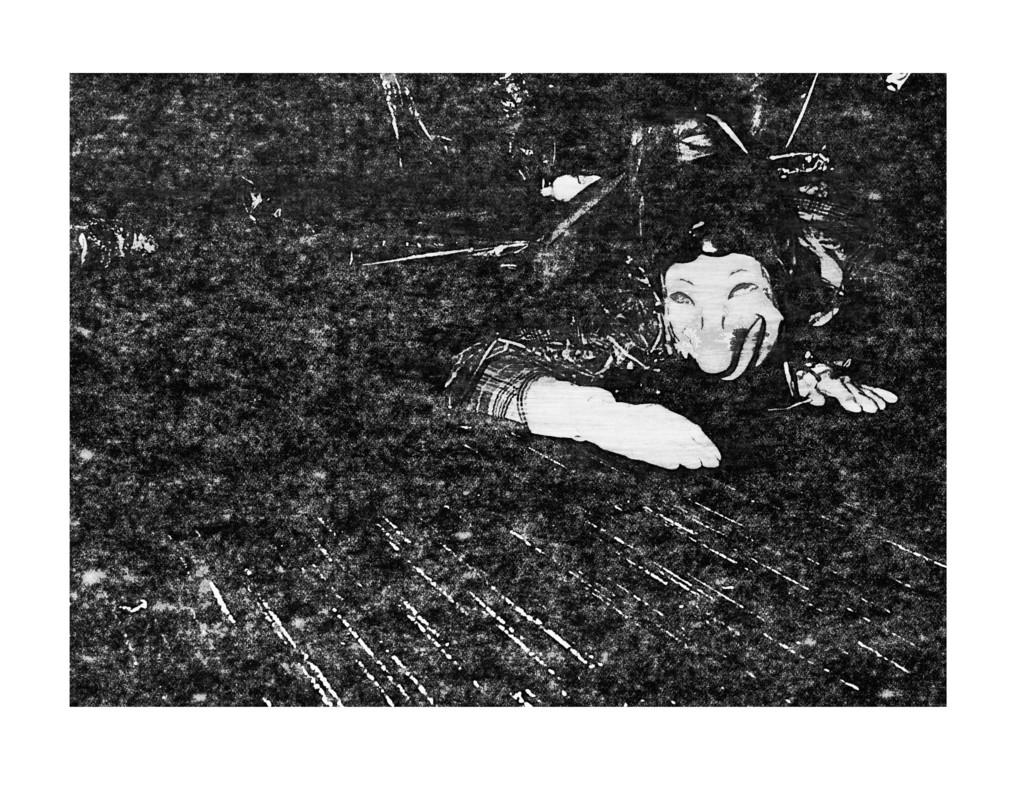What is the overall lighting condition in the image? The image is dark. Can you describe the main subject in the image? There is a person in the image. What type of texture can be seen on the cat's fur in the image? There is no cat present in the image, so we cannot determine the texture of its fur. 